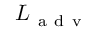Convert formula to latex. <formula><loc_0><loc_0><loc_500><loc_500>L _ { a d v }</formula> 